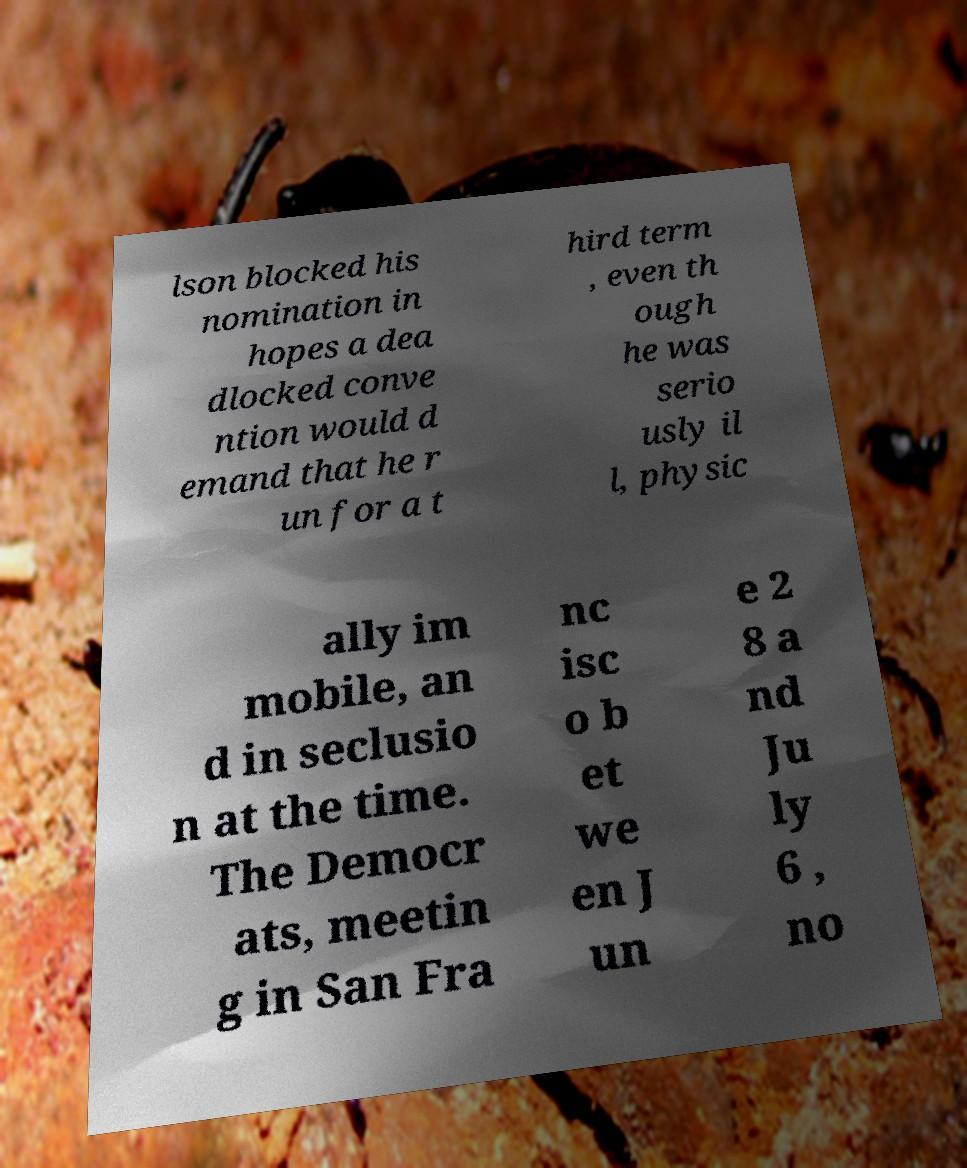Please read and relay the text visible in this image. What does it say? lson blocked his nomination in hopes a dea dlocked conve ntion would d emand that he r un for a t hird term , even th ough he was serio usly il l, physic ally im mobile, an d in seclusio n at the time. The Democr ats, meetin g in San Fra nc isc o b et we en J un e 2 8 a nd Ju ly 6 , no 